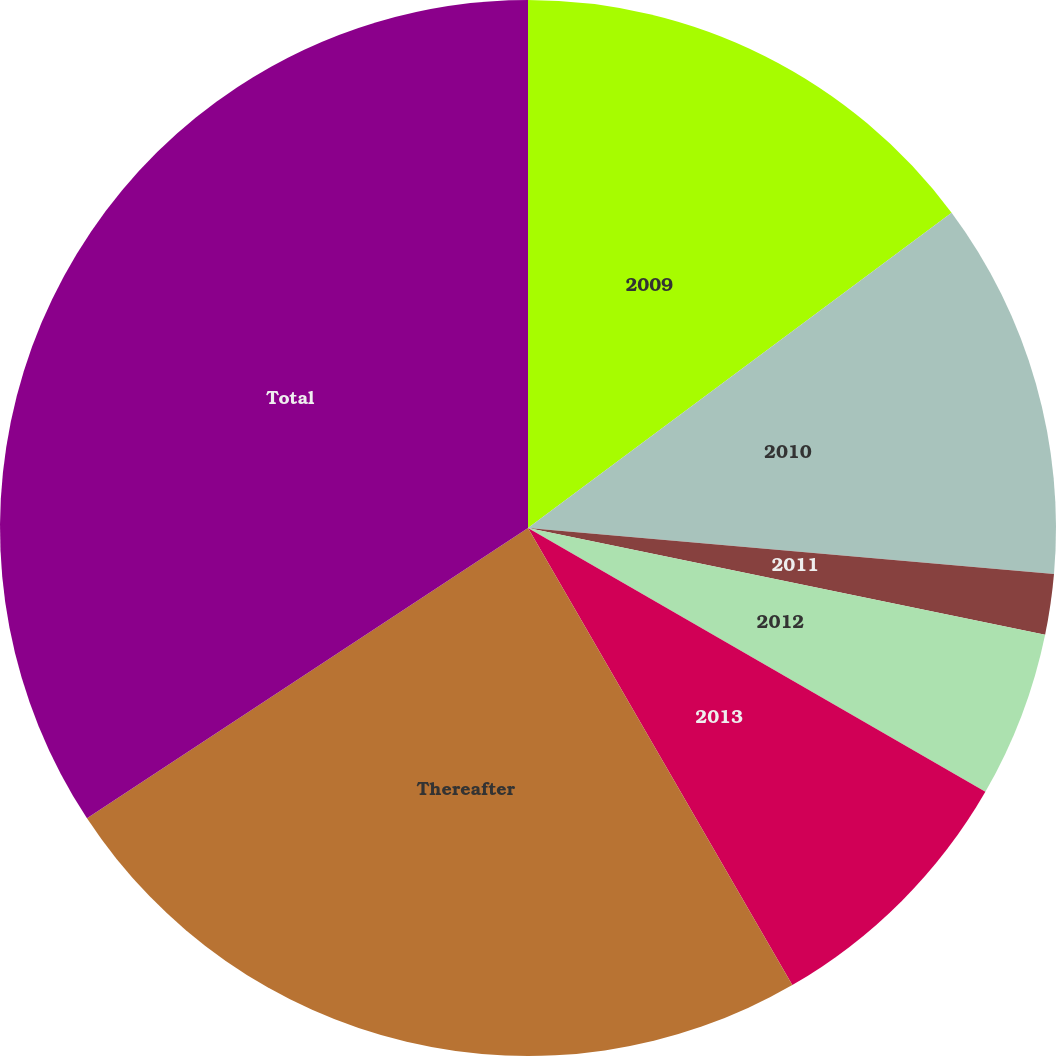Convert chart to OTSL. <chart><loc_0><loc_0><loc_500><loc_500><pie_chart><fcel>2009<fcel>2010<fcel>2011<fcel>2012<fcel>2013<fcel>Thereafter<fcel>Total<nl><fcel>14.82%<fcel>11.57%<fcel>1.85%<fcel>5.09%<fcel>8.33%<fcel>24.08%<fcel>34.27%<nl></chart> 